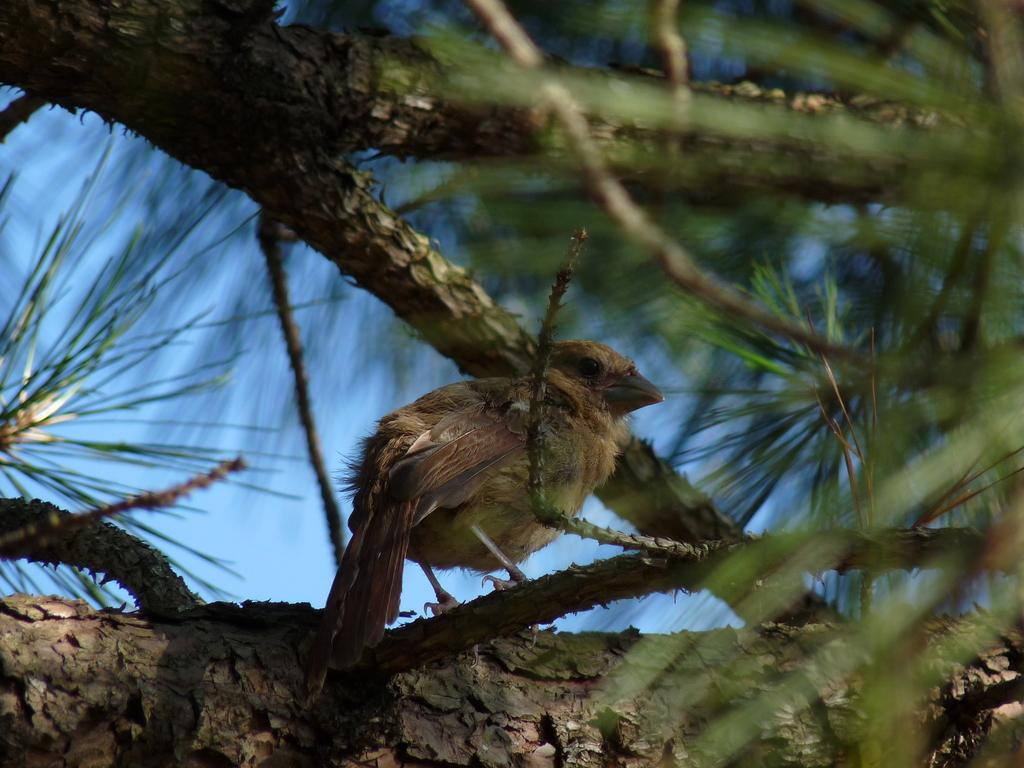What type of animal can be seen in the image? There is a bird in the image. Where is the bird located in the image? The bird is on the branch of a tree. What part of the natural environment is visible in the image? The sky is visible in the image. What is the bird's income in the image? Birds do not have income, so this question cannot be answered based on the image. 